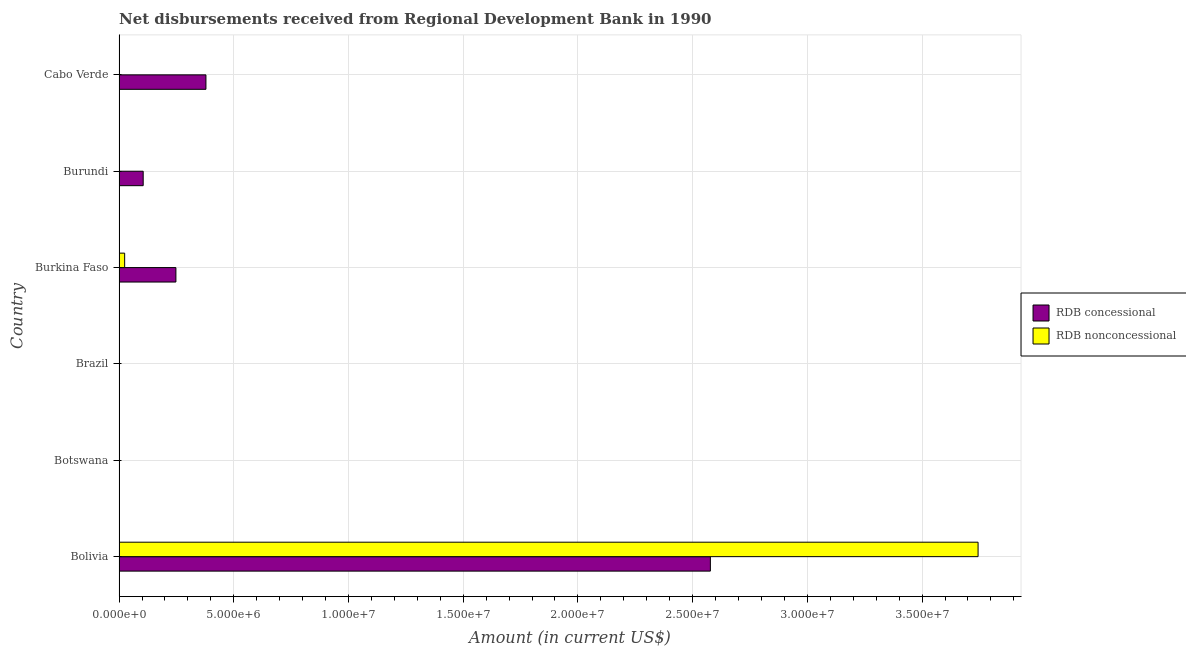How many different coloured bars are there?
Offer a terse response. 2. Are the number of bars per tick equal to the number of legend labels?
Offer a very short reply. No. Are the number of bars on each tick of the Y-axis equal?
Your answer should be very brief. No. How many bars are there on the 6th tick from the top?
Make the answer very short. 2. How many bars are there on the 2nd tick from the bottom?
Give a very brief answer. 0. What is the label of the 3rd group of bars from the top?
Provide a short and direct response. Burkina Faso. What is the net non concessional disbursements from rdb in Botswana?
Give a very brief answer. 0. Across all countries, what is the maximum net non concessional disbursements from rdb?
Your response must be concise. 3.74e+07. Across all countries, what is the minimum net concessional disbursements from rdb?
Make the answer very short. 0. What is the total net non concessional disbursements from rdb in the graph?
Ensure brevity in your answer.  3.77e+07. What is the difference between the net non concessional disbursements from rdb in Bolivia and that in Burkina Faso?
Ensure brevity in your answer.  3.72e+07. What is the difference between the net non concessional disbursements from rdb in Botswana and the net concessional disbursements from rdb in Bolivia?
Give a very brief answer. -2.58e+07. What is the average net non concessional disbursements from rdb per country?
Your answer should be very brief. 6.28e+06. What is the difference between the net concessional disbursements from rdb and net non concessional disbursements from rdb in Burkina Faso?
Provide a short and direct response. 2.23e+06. What is the ratio of the net concessional disbursements from rdb in Burundi to that in Cabo Verde?
Offer a very short reply. 0.28. What is the difference between the highest and the second highest net concessional disbursements from rdb?
Your answer should be very brief. 2.20e+07. What is the difference between the highest and the lowest net concessional disbursements from rdb?
Offer a very short reply. 2.58e+07. In how many countries, is the net non concessional disbursements from rdb greater than the average net non concessional disbursements from rdb taken over all countries?
Keep it short and to the point. 1. How many bars are there?
Provide a short and direct response. 6. Are all the bars in the graph horizontal?
Provide a succinct answer. Yes. How many countries are there in the graph?
Your answer should be very brief. 6. Where does the legend appear in the graph?
Make the answer very short. Center right. What is the title of the graph?
Give a very brief answer. Net disbursements received from Regional Development Bank in 1990. Does "Taxes" appear as one of the legend labels in the graph?
Your response must be concise. No. What is the label or title of the Y-axis?
Make the answer very short. Country. What is the Amount (in current US$) in RDB concessional in Bolivia?
Offer a terse response. 2.58e+07. What is the Amount (in current US$) of RDB nonconcessional in Bolivia?
Your answer should be compact. 3.74e+07. What is the Amount (in current US$) of RDB concessional in Botswana?
Offer a very short reply. 0. What is the Amount (in current US$) of RDB nonconcessional in Botswana?
Make the answer very short. 0. What is the Amount (in current US$) of RDB nonconcessional in Brazil?
Provide a short and direct response. 0. What is the Amount (in current US$) of RDB concessional in Burkina Faso?
Offer a terse response. 2.48e+06. What is the Amount (in current US$) in RDB nonconcessional in Burkina Faso?
Your response must be concise. 2.44e+05. What is the Amount (in current US$) in RDB concessional in Burundi?
Keep it short and to the point. 1.05e+06. What is the Amount (in current US$) in RDB nonconcessional in Burundi?
Your response must be concise. 0. What is the Amount (in current US$) of RDB concessional in Cabo Verde?
Make the answer very short. 3.79e+06. What is the Amount (in current US$) of RDB nonconcessional in Cabo Verde?
Your response must be concise. 0. Across all countries, what is the maximum Amount (in current US$) of RDB concessional?
Make the answer very short. 2.58e+07. Across all countries, what is the maximum Amount (in current US$) in RDB nonconcessional?
Your answer should be compact. 3.74e+07. Across all countries, what is the minimum Amount (in current US$) of RDB concessional?
Your response must be concise. 0. What is the total Amount (in current US$) in RDB concessional in the graph?
Provide a short and direct response. 3.31e+07. What is the total Amount (in current US$) in RDB nonconcessional in the graph?
Provide a short and direct response. 3.77e+07. What is the difference between the Amount (in current US$) in RDB concessional in Bolivia and that in Burkina Faso?
Your response must be concise. 2.33e+07. What is the difference between the Amount (in current US$) of RDB nonconcessional in Bolivia and that in Burkina Faso?
Give a very brief answer. 3.72e+07. What is the difference between the Amount (in current US$) in RDB concessional in Bolivia and that in Burundi?
Your answer should be very brief. 2.47e+07. What is the difference between the Amount (in current US$) in RDB concessional in Bolivia and that in Cabo Verde?
Keep it short and to the point. 2.20e+07. What is the difference between the Amount (in current US$) of RDB concessional in Burkina Faso and that in Burundi?
Your response must be concise. 1.43e+06. What is the difference between the Amount (in current US$) in RDB concessional in Burkina Faso and that in Cabo Verde?
Provide a short and direct response. -1.31e+06. What is the difference between the Amount (in current US$) in RDB concessional in Burundi and that in Cabo Verde?
Your response must be concise. -2.74e+06. What is the difference between the Amount (in current US$) of RDB concessional in Bolivia and the Amount (in current US$) of RDB nonconcessional in Burkina Faso?
Your answer should be very brief. 2.55e+07. What is the average Amount (in current US$) of RDB concessional per country?
Make the answer very short. 5.52e+06. What is the average Amount (in current US$) of RDB nonconcessional per country?
Provide a short and direct response. 6.28e+06. What is the difference between the Amount (in current US$) in RDB concessional and Amount (in current US$) in RDB nonconcessional in Bolivia?
Your response must be concise. -1.17e+07. What is the difference between the Amount (in current US$) of RDB concessional and Amount (in current US$) of RDB nonconcessional in Burkina Faso?
Ensure brevity in your answer.  2.23e+06. What is the ratio of the Amount (in current US$) in RDB concessional in Bolivia to that in Burkina Faso?
Give a very brief answer. 10.4. What is the ratio of the Amount (in current US$) in RDB nonconcessional in Bolivia to that in Burkina Faso?
Your answer should be very brief. 153.45. What is the ratio of the Amount (in current US$) of RDB concessional in Bolivia to that in Burundi?
Provide a succinct answer. 24.5. What is the ratio of the Amount (in current US$) in RDB concessional in Bolivia to that in Cabo Verde?
Provide a short and direct response. 6.81. What is the ratio of the Amount (in current US$) in RDB concessional in Burkina Faso to that in Burundi?
Keep it short and to the point. 2.36. What is the ratio of the Amount (in current US$) in RDB concessional in Burkina Faso to that in Cabo Verde?
Your answer should be compact. 0.65. What is the ratio of the Amount (in current US$) in RDB concessional in Burundi to that in Cabo Verde?
Keep it short and to the point. 0.28. What is the difference between the highest and the second highest Amount (in current US$) of RDB concessional?
Provide a short and direct response. 2.20e+07. What is the difference between the highest and the lowest Amount (in current US$) of RDB concessional?
Provide a succinct answer. 2.58e+07. What is the difference between the highest and the lowest Amount (in current US$) in RDB nonconcessional?
Give a very brief answer. 3.74e+07. 